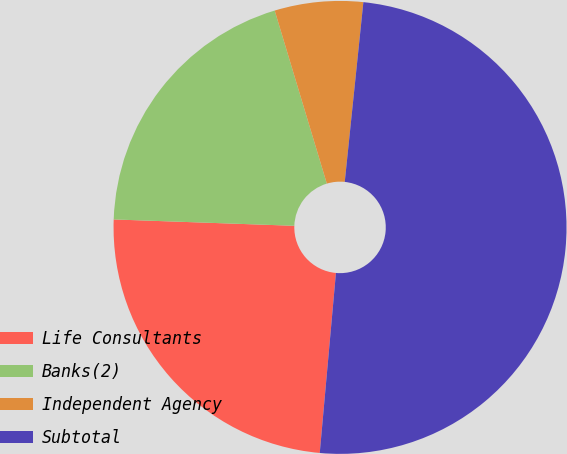<chart> <loc_0><loc_0><loc_500><loc_500><pie_chart><fcel>Life Consultants<fcel>Banks(2)<fcel>Independent Agency<fcel>Subtotal<nl><fcel>24.13%<fcel>19.78%<fcel>6.3%<fcel>49.78%<nl></chart> 